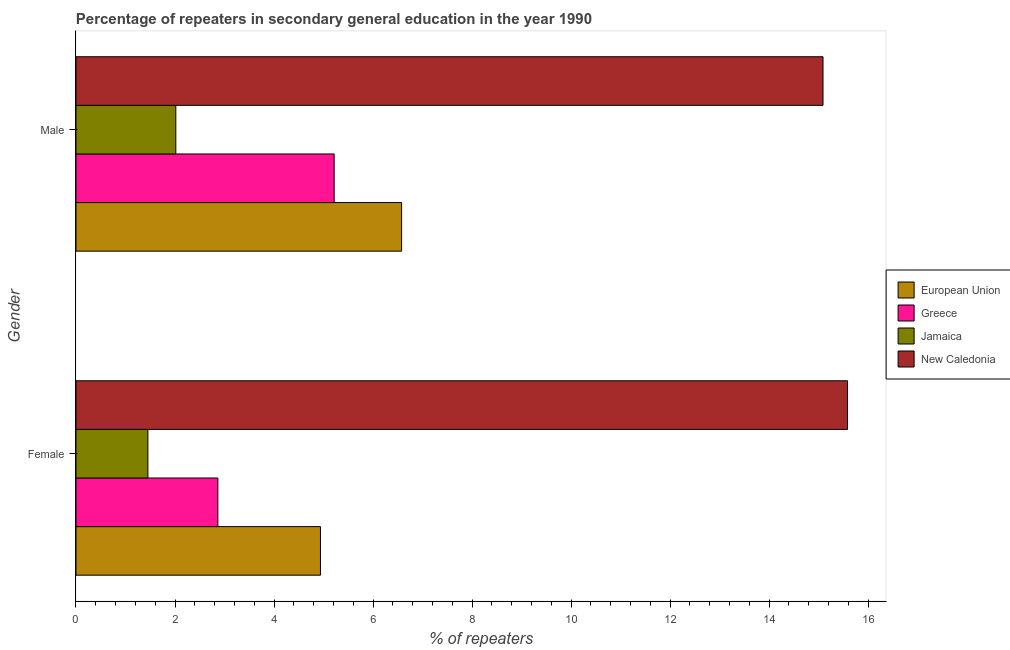Are the number of bars on each tick of the Y-axis equal?
Provide a short and direct response. Yes. How many bars are there on the 1st tick from the bottom?
Ensure brevity in your answer.  4. What is the label of the 1st group of bars from the top?
Your answer should be very brief. Male. What is the percentage of female repeaters in Greece?
Your answer should be compact. 2.87. Across all countries, what is the maximum percentage of male repeaters?
Your answer should be very brief. 15.09. Across all countries, what is the minimum percentage of female repeaters?
Your answer should be very brief. 1.45. In which country was the percentage of male repeaters maximum?
Your response must be concise. New Caledonia. In which country was the percentage of female repeaters minimum?
Keep it short and to the point. Jamaica. What is the total percentage of male repeaters in the graph?
Provide a succinct answer. 28.89. What is the difference between the percentage of female repeaters in Greece and that in Jamaica?
Give a very brief answer. 1.41. What is the difference between the percentage of female repeaters in Greece and the percentage of male repeaters in New Caledonia?
Ensure brevity in your answer.  -12.22. What is the average percentage of male repeaters per country?
Provide a short and direct response. 7.22. What is the difference between the percentage of female repeaters and percentage of male repeaters in Greece?
Provide a short and direct response. -2.35. What is the ratio of the percentage of female repeaters in Greece to that in European Union?
Make the answer very short. 0.58. Is the percentage of female repeaters in New Caledonia less than that in Greece?
Give a very brief answer. No. What does the 2nd bar from the top in Female represents?
Provide a short and direct response. Jamaica. How many bars are there?
Offer a very short reply. 8. What is the difference between two consecutive major ticks on the X-axis?
Ensure brevity in your answer.  2. Are the values on the major ticks of X-axis written in scientific E-notation?
Provide a succinct answer. No. How are the legend labels stacked?
Your answer should be compact. Vertical. What is the title of the graph?
Your answer should be compact. Percentage of repeaters in secondary general education in the year 1990. Does "Europe(all income levels)" appear as one of the legend labels in the graph?
Offer a very short reply. No. What is the label or title of the X-axis?
Your response must be concise. % of repeaters. What is the label or title of the Y-axis?
Offer a very short reply. Gender. What is the % of repeaters of European Union in Female?
Ensure brevity in your answer.  4.94. What is the % of repeaters in Greece in Female?
Your answer should be compact. 2.87. What is the % of repeaters in Jamaica in Female?
Your answer should be very brief. 1.45. What is the % of repeaters of New Caledonia in Female?
Provide a short and direct response. 15.58. What is the % of repeaters of European Union in Male?
Offer a terse response. 6.58. What is the % of repeaters in Greece in Male?
Ensure brevity in your answer.  5.21. What is the % of repeaters of Jamaica in Male?
Provide a short and direct response. 2.02. What is the % of repeaters of New Caledonia in Male?
Offer a very short reply. 15.09. Across all Gender, what is the maximum % of repeaters of European Union?
Provide a succinct answer. 6.58. Across all Gender, what is the maximum % of repeaters in Greece?
Your answer should be compact. 5.21. Across all Gender, what is the maximum % of repeaters in Jamaica?
Your response must be concise. 2.02. Across all Gender, what is the maximum % of repeaters in New Caledonia?
Your answer should be very brief. 15.58. Across all Gender, what is the minimum % of repeaters in European Union?
Your answer should be very brief. 4.94. Across all Gender, what is the minimum % of repeaters in Greece?
Your answer should be compact. 2.87. Across all Gender, what is the minimum % of repeaters of Jamaica?
Your response must be concise. 1.45. Across all Gender, what is the minimum % of repeaters in New Caledonia?
Your answer should be compact. 15.09. What is the total % of repeaters in European Union in the graph?
Provide a short and direct response. 11.51. What is the total % of repeaters of Greece in the graph?
Make the answer very short. 8.08. What is the total % of repeaters of Jamaica in the graph?
Provide a short and direct response. 3.47. What is the total % of repeaters of New Caledonia in the graph?
Offer a very short reply. 30.67. What is the difference between the % of repeaters in European Union in Female and that in Male?
Offer a very short reply. -1.64. What is the difference between the % of repeaters of Greece in Female and that in Male?
Your answer should be compact. -2.35. What is the difference between the % of repeaters in Jamaica in Female and that in Male?
Keep it short and to the point. -0.56. What is the difference between the % of repeaters in New Caledonia in Female and that in Male?
Give a very brief answer. 0.49. What is the difference between the % of repeaters in European Union in Female and the % of repeaters in Greece in Male?
Your response must be concise. -0.28. What is the difference between the % of repeaters in European Union in Female and the % of repeaters in Jamaica in Male?
Make the answer very short. 2.92. What is the difference between the % of repeaters of European Union in Female and the % of repeaters of New Caledonia in Male?
Ensure brevity in your answer.  -10.15. What is the difference between the % of repeaters of Greece in Female and the % of repeaters of Jamaica in Male?
Make the answer very short. 0.85. What is the difference between the % of repeaters of Greece in Female and the % of repeaters of New Caledonia in Male?
Your answer should be very brief. -12.22. What is the difference between the % of repeaters of Jamaica in Female and the % of repeaters of New Caledonia in Male?
Offer a terse response. -13.64. What is the average % of repeaters in European Union per Gender?
Your answer should be very brief. 5.76. What is the average % of repeaters of Greece per Gender?
Your answer should be compact. 4.04. What is the average % of repeaters in Jamaica per Gender?
Give a very brief answer. 1.73. What is the average % of repeaters of New Caledonia per Gender?
Keep it short and to the point. 15.34. What is the difference between the % of repeaters in European Union and % of repeaters in Greece in Female?
Your response must be concise. 2.07. What is the difference between the % of repeaters in European Union and % of repeaters in Jamaica in Female?
Make the answer very short. 3.48. What is the difference between the % of repeaters in European Union and % of repeaters in New Caledonia in Female?
Provide a succinct answer. -10.65. What is the difference between the % of repeaters in Greece and % of repeaters in Jamaica in Female?
Keep it short and to the point. 1.41. What is the difference between the % of repeaters of Greece and % of repeaters of New Caledonia in Female?
Provide a succinct answer. -12.72. What is the difference between the % of repeaters in Jamaica and % of repeaters in New Caledonia in Female?
Offer a terse response. -14.13. What is the difference between the % of repeaters of European Union and % of repeaters of Greece in Male?
Your response must be concise. 1.36. What is the difference between the % of repeaters in European Union and % of repeaters in Jamaica in Male?
Your response must be concise. 4.56. What is the difference between the % of repeaters of European Union and % of repeaters of New Caledonia in Male?
Your answer should be very brief. -8.51. What is the difference between the % of repeaters of Greece and % of repeaters of Jamaica in Male?
Make the answer very short. 3.2. What is the difference between the % of repeaters of Greece and % of repeaters of New Caledonia in Male?
Your response must be concise. -9.87. What is the difference between the % of repeaters of Jamaica and % of repeaters of New Caledonia in Male?
Keep it short and to the point. -13.07. What is the ratio of the % of repeaters in European Union in Female to that in Male?
Provide a succinct answer. 0.75. What is the ratio of the % of repeaters of Greece in Female to that in Male?
Keep it short and to the point. 0.55. What is the ratio of the % of repeaters of Jamaica in Female to that in Male?
Provide a succinct answer. 0.72. What is the ratio of the % of repeaters of New Caledonia in Female to that in Male?
Give a very brief answer. 1.03. What is the difference between the highest and the second highest % of repeaters of European Union?
Ensure brevity in your answer.  1.64. What is the difference between the highest and the second highest % of repeaters in Greece?
Your response must be concise. 2.35. What is the difference between the highest and the second highest % of repeaters in Jamaica?
Your answer should be compact. 0.56. What is the difference between the highest and the second highest % of repeaters in New Caledonia?
Your response must be concise. 0.49. What is the difference between the highest and the lowest % of repeaters in European Union?
Give a very brief answer. 1.64. What is the difference between the highest and the lowest % of repeaters in Greece?
Your answer should be compact. 2.35. What is the difference between the highest and the lowest % of repeaters in Jamaica?
Your response must be concise. 0.56. What is the difference between the highest and the lowest % of repeaters of New Caledonia?
Provide a succinct answer. 0.49. 